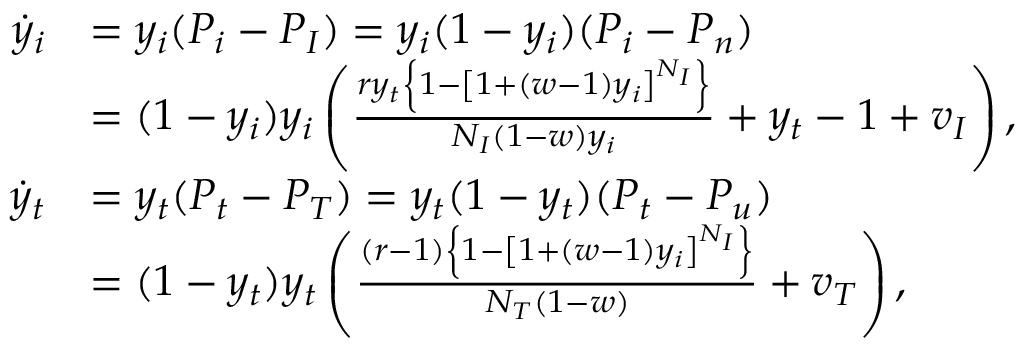<formula> <loc_0><loc_0><loc_500><loc_500>\begin{array} { r l } { \dot { y } _ { i } } & { = y _ { i } ( P _ { i } - P _ { I } ) = y _ { i } ( 1 - y _ { i } ) ( P _ { i } - P _ { n } ) } \\ & { = ( 1 - y _ { i } ) y _ { i } \left ( \frac { r y _ { t } \left \{ 1 - \left [ 1 + ( w - 1 ) y _ { i } \right ] ^ { N _ { I } } \right \} } { N _ { I } ( 1 - w ) y _ { i } } + y _ { t } - 1 + v _ { I } \right ) , } \\ { \dot { y } _ { t } } & { = y _ { t } ( P _ { t } - P _ { T } ) = y _ { t } ( 1 - y _ { t } ) ( P _ { t } - P _ { u } ) } \\ & { = ( 1 - y _ { t } ) y _ { t } \left ( \frac { ( r - 1 ) \left \{ 1 - \left [ 1 + ( w - 1 ) y _ { i } \right ] ^ { N _ { I } } \right \} } { N _ { T } ( 1 - w ) } + v _ { T } \right ) , } \end{array}</formula> 